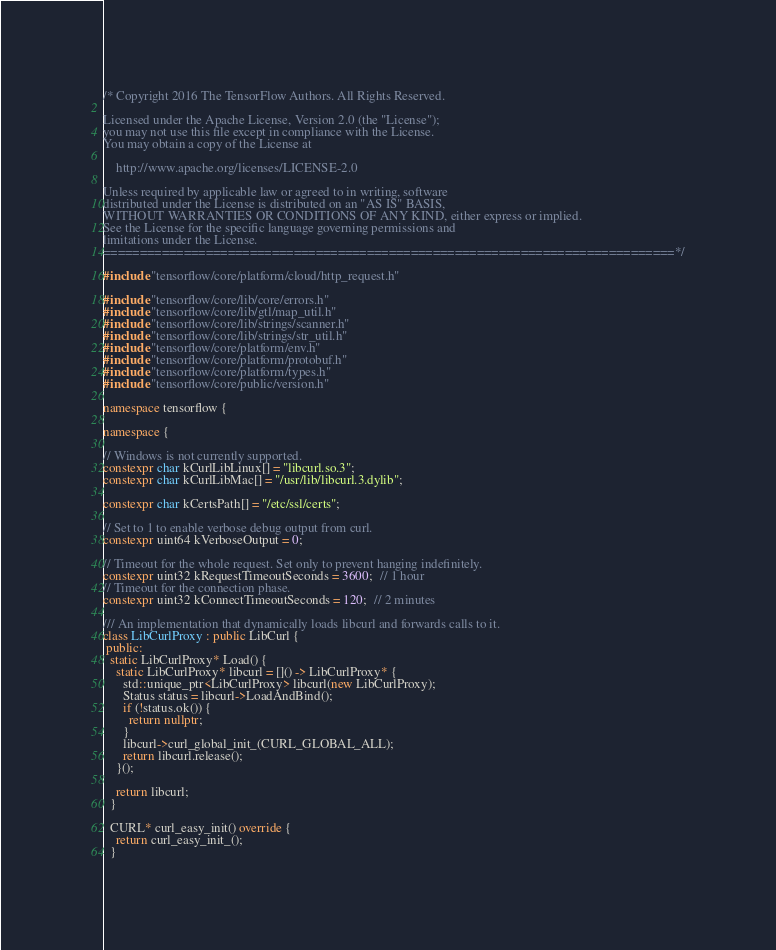Convert code to text. <code><loc_0><loc_0><loc_500><loc_500><_C++_>/* Copyright 2016 The TensorFlow Authors. All Rights Reserved.

Licensed under the Apache License, Version 2.0 (the "License");
you may not use this file except in compliance with the License.
You may obtain a copy of the License at

    http://www.apache.org/licenses/LICENSE-2.0

Unless required by applicable law or agreed to in writing, software
distributed under the License is distributed on an "AS IS" BASIS,
WITHOUT WARRANTIES OR CONDITIONS OF ANY KIND, either express or implied.
See the License for the specific language governing permissions and
limitations under the License.
==============================================================================*/

#include "tensorflow/core/platform/cloud/http_request.h"

#include "tensorflow/core/lib/core/errors.h"
#include "tensorflow/core/lib/gtl/map_util.h"
#include "tensorflow/core/lib/strings/scanner.h"
#include "tensorflow/core/lib/strings/str_util.h"
#include "tensorflow/core/platform/env.h"
#include "tensorflow/core/platform/protobuf.h"
#include "tensorflow/core/platform/types.h"
#include "tensorflow/core/public/version.h"

namespace tensorflow {

namespace {

// Windows is not currently supported.
constexpr char kCurlLibLinux[] = "libcurl.so.3";
constexpr char kCurlLibMac[] = "/usr/lib/libcurl.3.dylib";

constexpr char kCertsPath[] = "/etc/ssl/certs";

// Set to 1 to enable verbose debug output from curl.
constexpr uint64 kVerboseOutput = 0;

// Timeout for the whole request. Set only to prevent hanging indefinitely.
constexpr uint32 kRequestTimeoutSeconds = 3600;  // 1 hour
// Timeout for the connection phase.
constexpr uint32 kConnectTimeoutSeconds = 120;  // 2 minutes

/// An implementation that dynamically loads libcurl and forwards calls to it.
class LibCurlProxy : public LibCurl {
 public:
  static LibCurlProxy* Load() {
    static LibCurlProxy* libcurl = []() -> LibCurlProxy* {
      std::unique_ptr<LibCurlProxy> libcurl(new LibCurlProxy);
      Status status = libcurl->LoadAndBind();
      if (!status.ok()) {
        return nullptr;
      }
      libcurl->curl_global_init_(CURL_GLOBAL_ALL);
      return libcurl.release();
    }();

    return libcurl;
  }

  CURL* curl_easy_init() override {
    return curl_easy_init_();
  }
</code> 